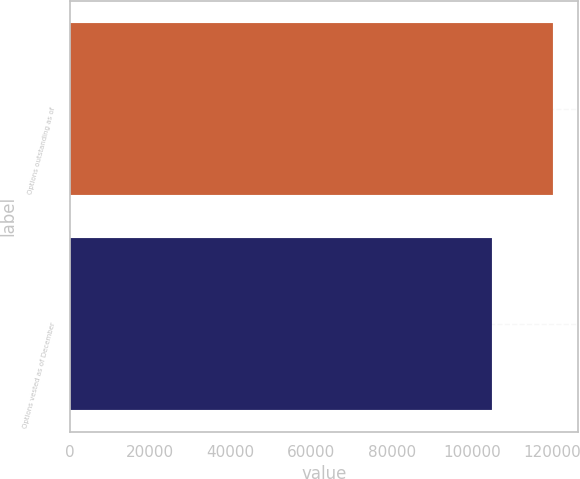Convert chart. <chart><loc_0><loc_0><loc_500><loc_500><bar_chart><fcel>Options outstanding as of<fcel>Options vested as of December<nl><fcel>120215<fcel>104852<nl></chart> 